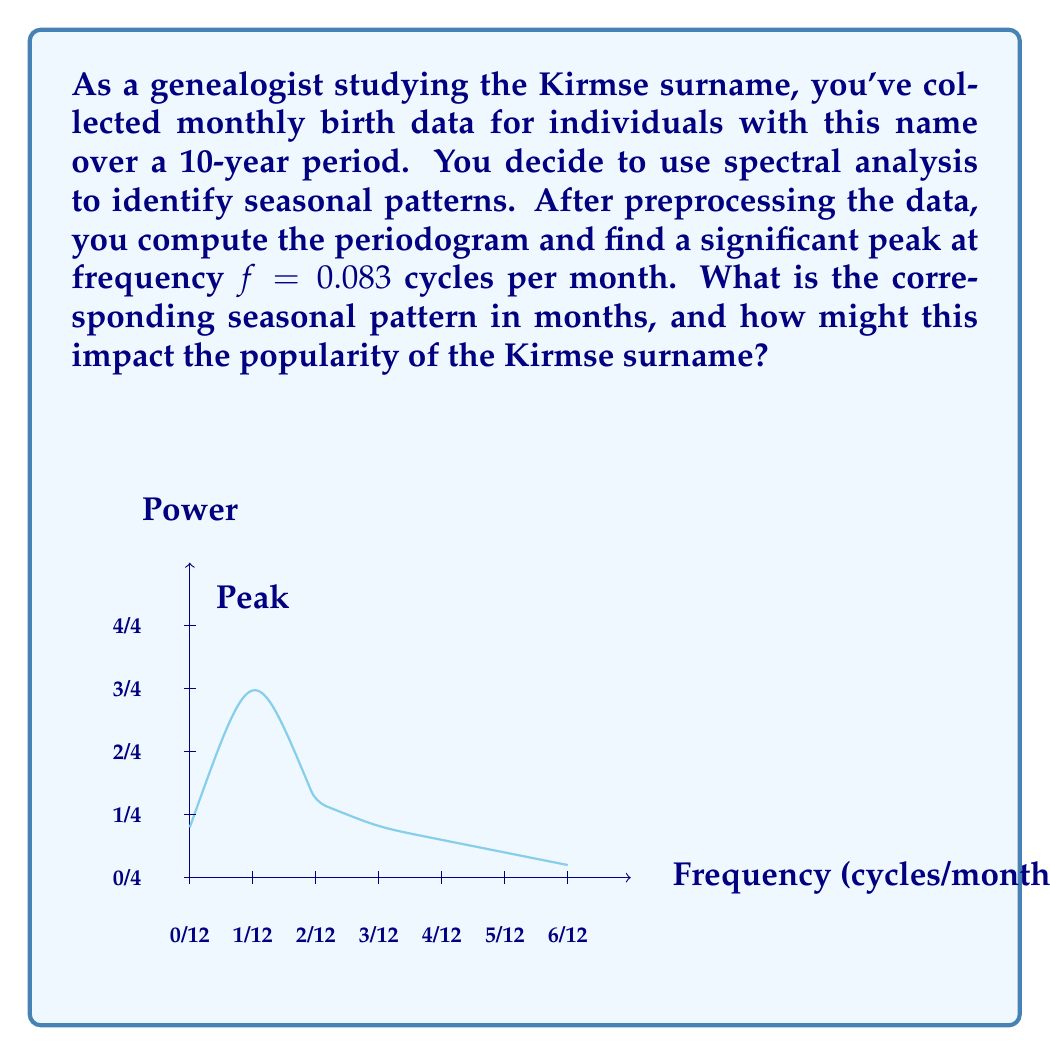Teach me how to tackle this problem. To solve this problem, we'll follow these steps:

1) The frequency $f$ is given in cycles per month. To find the period $T$ in months, we use the relationship:

   $$T = \frac{1}{f}$$

2) Substituting the given frequency:

   $$T = \frac{1}{0.083} \approx 12.05 \text{ months}$$

3) This period corresponds closely to an annual cycle (12 months), indicating a yearly seasonal pattern in births for individuals with the Kirmse surname.

4) To interpret this result in the context of name popularity:
   - There appears to be a strong annual cycle in births for individuals named Kirmse.
   - This could suggest that the name is more commonly given at a particular time of year, possibly due to cultural, religious, or social factors.
   - For example, if the peak occurs in spring, it might indicate a preference for giving this name to children born in that season.

5) Impact on name popularity:
   - The seasonal pattern could lead to fluctuations in the name's popularity throughout the year.
   - It might create "cohorts" of Kirmses born around the same time each year, potentially affecting social dynamics within the Kirmse community.
   - Understanding this pattern could help predict future trends in the name's usage and provide insights into the cultural factors influencing naming practices for this surname.
Answer: 12-month seasonal cycle; annual fluctuations in name popularity 